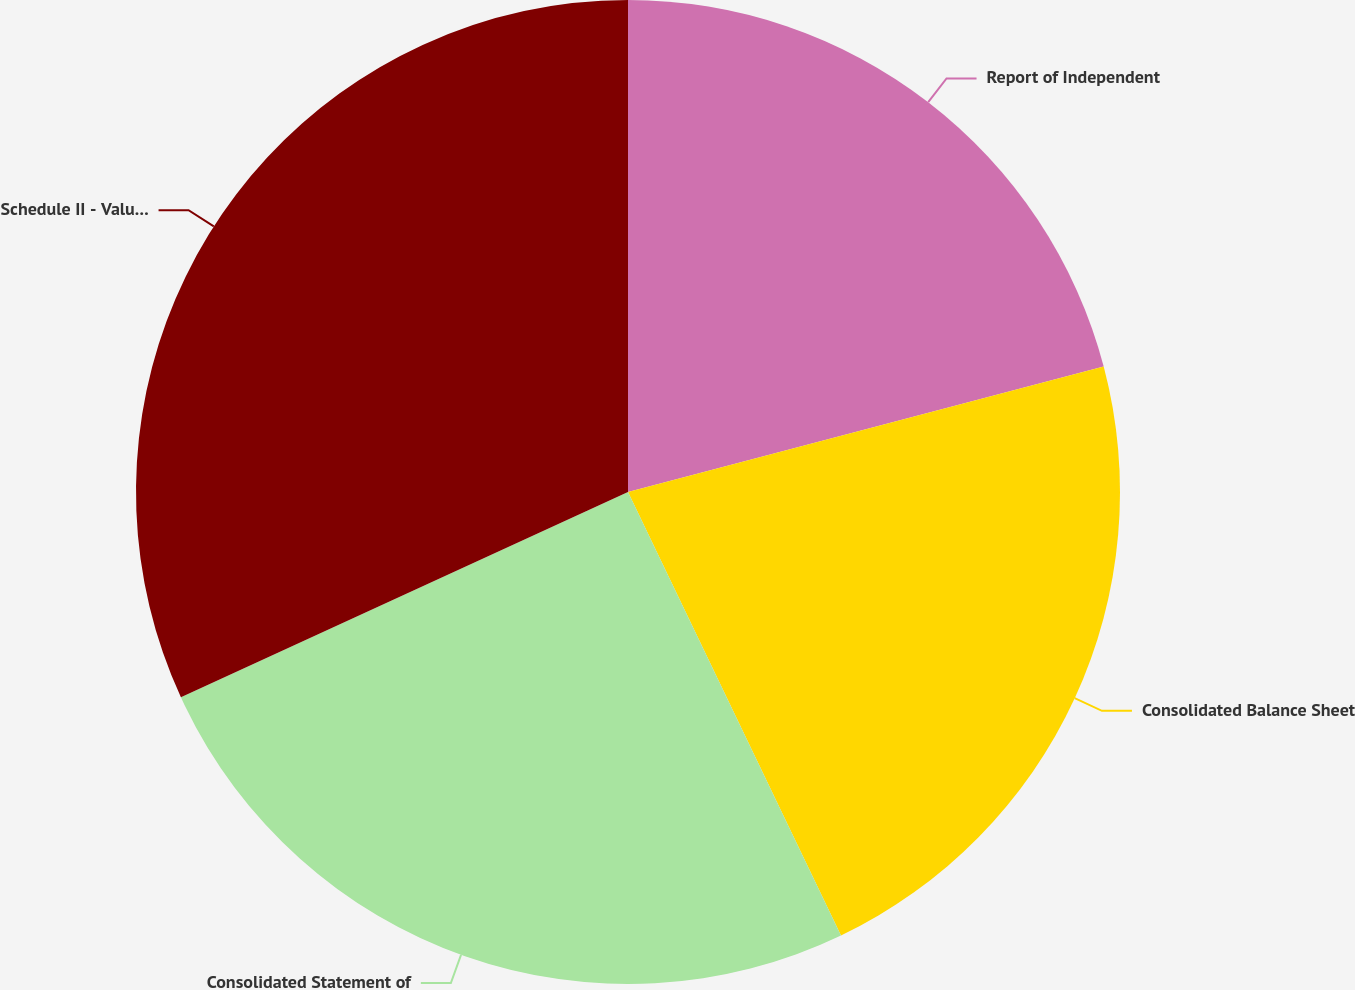Convert chart to OTSL. <chart><loc_0><loc_0><loc_500><loc_500><pie_chart><fcel>Report of Independent<fcel>Consolidated Balance Sheet<fcel>Consolidated Statement of<fcel>Schedule II - Valuation and<nl><fcel>20.89%<fcel>21.98%<fcel>25.27%<fcel>31.85%<nl></chart> 